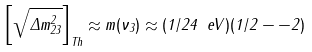Convert formula to latex. <formula><loc_0><loc_0><loc_500><loc_500>\left [ \sqrt { \Delta m _ { 2 3 } ^ { 2 } } \right ] _ { T h } \approx m ( \nu _ { 3 } ) \approx ( 1 / 2 4 \ e V ) ( 1 / 2 - - 2 )</formula> 